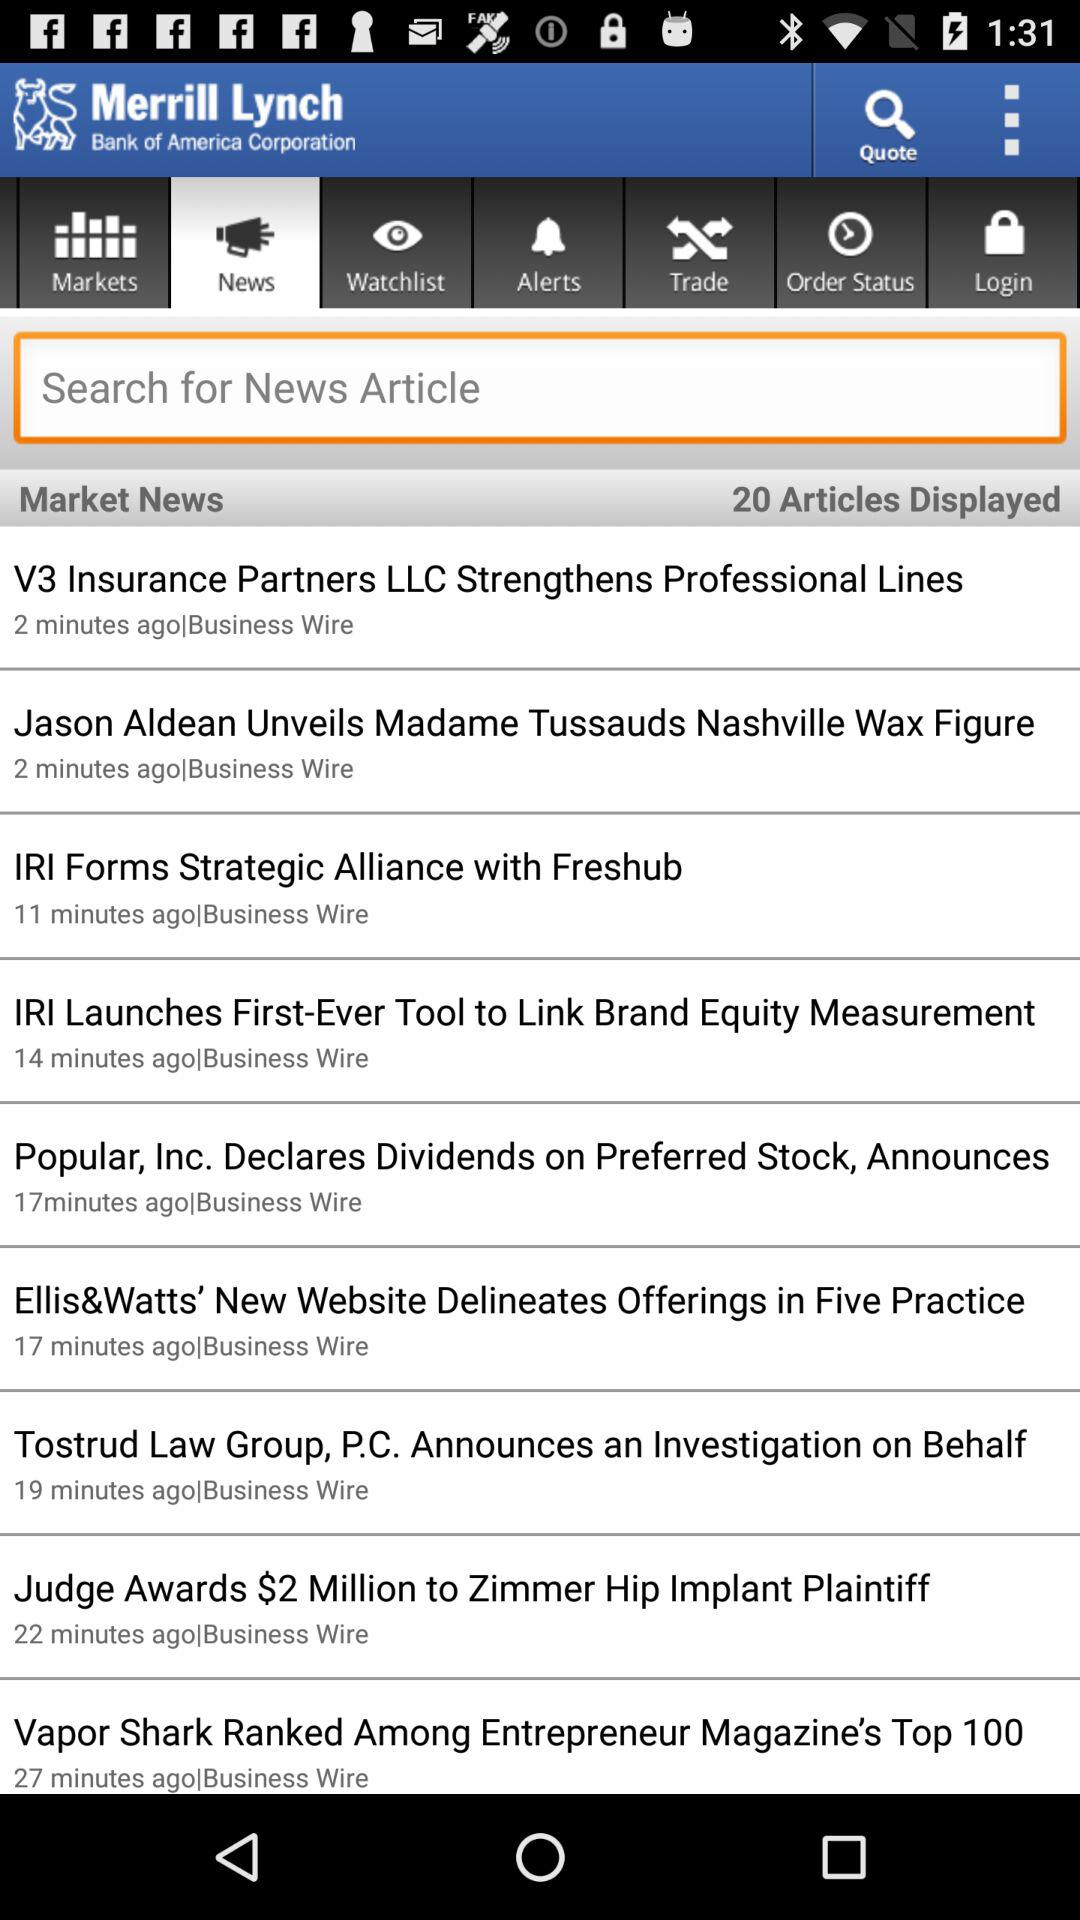How many total articles are displayed? There are 20 articles displayed. 